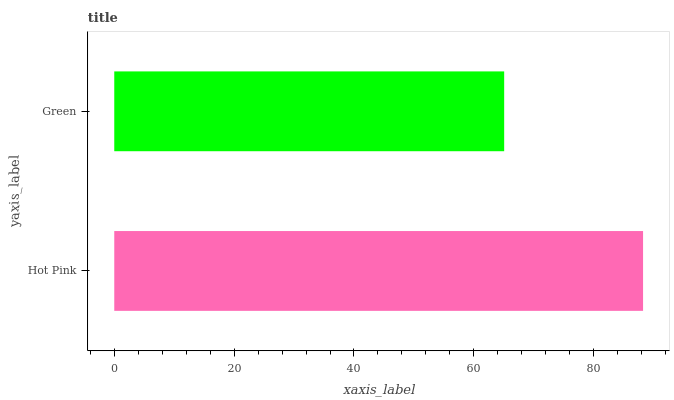Is Green the minimum?
Answer yes or no. Yes. Is Hot Pink the maximum?
Answer yes or no. Yes. Is Green the maximum?
Answer yes or no. No. Is Hot Pink greater than Green?
Answer yes or no. Yes. Is Green less than Hot Pink?
Answer yes or no. Yes. Is Green greater than Hot Pink?
Answer yes or no. No. Is Hot Pink less than Green?
Answer yes or no. No. Is Hot Pink the high median?
Answer yes or no. Yes. Is Green the low median?
Answer yes or no. Yes. Is Green the high median?
Answer yes or no. No. Is Hot Pink the low median?
Answer yes or no. No. 